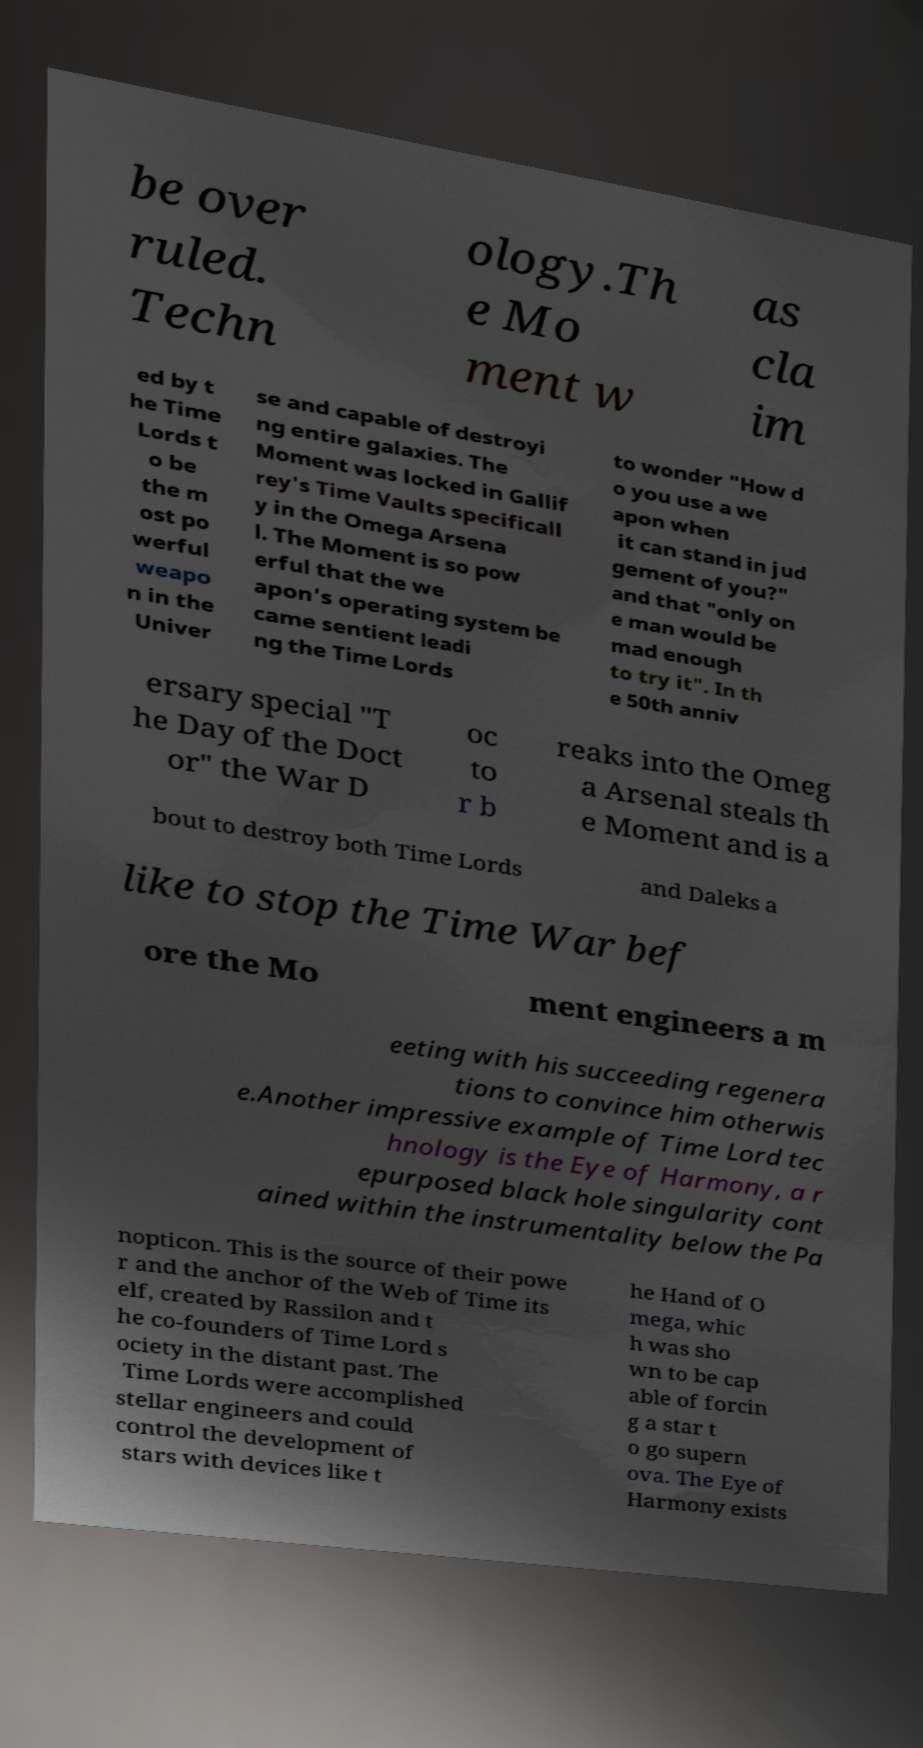There's text embedded in this image that I need extracted. Can you transcribe it verbatim? be over ruled. Techn ology.Th e Mo ment w as cla im ed by t he Time Lords t o be the m ost po werful weapo n in the Univer se and capable of destroyi ng entire galaxies. The Moment was locked in Gallif rey's Time Vaults specificall y in the Omega Arsena l. The Moment is so pow erful that the we apon's operating system be came sentient leadi ng the Time Lords to wonder "How d o you use a we apon when it can stand in jud gement of you?" and that "only on e man would be mad enough to try it". In th e 50th anniv ersary special "T he Day of the Doct or" the War D oc to r b reaks into the Omeg a Arsenal steals th e Moment and is a bout to destroy both Time Lords and Daleks a like to stop the Time War bef ore the Mo ment engineers a m eeting with his succeeding regenera tions to convince him otherwis e.Another impressive example of Time Lord tec hnology is the Eye of Harmony, a r epurposed black hole singularity cont ained within the instrumentality below the Pa nopticon. This is the source of their powe r and the anchor of the Web of Time its elf, created by Rassilon and t he co-founders of Time Lord s ociety in the distant past. The Time Lords were accomplished stellar engineers and could control the development of stars with devices like t he Hand of O mega, whic h was sho wn to be cap able of forcin g a star t o go supern ova. The Eye of Harmony exists 